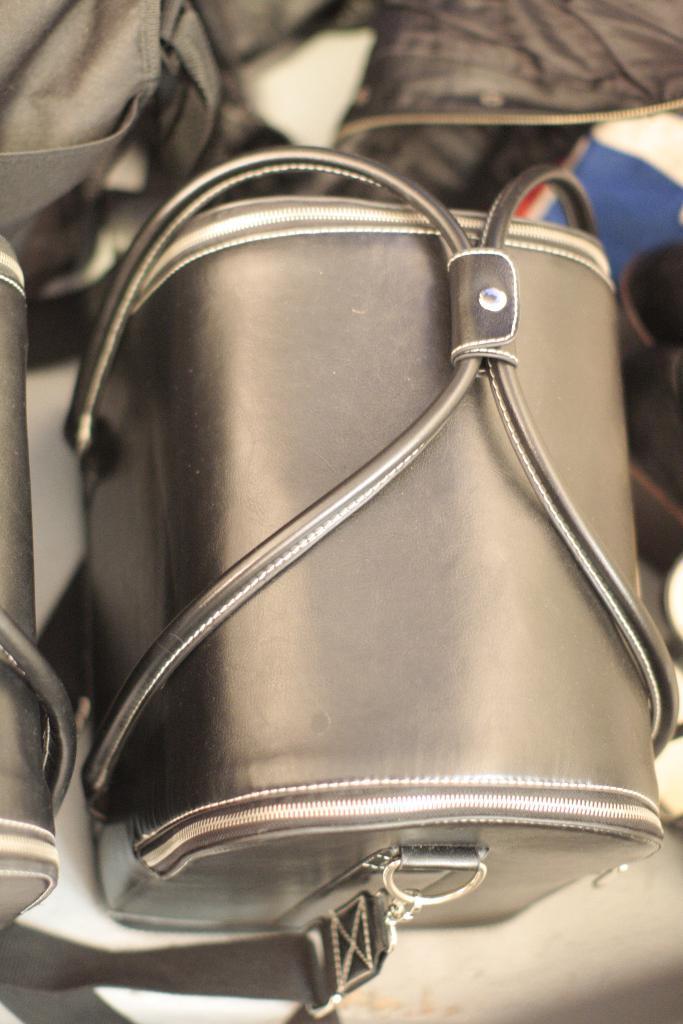Can you describe this image briefly? This picture shows a handbag 